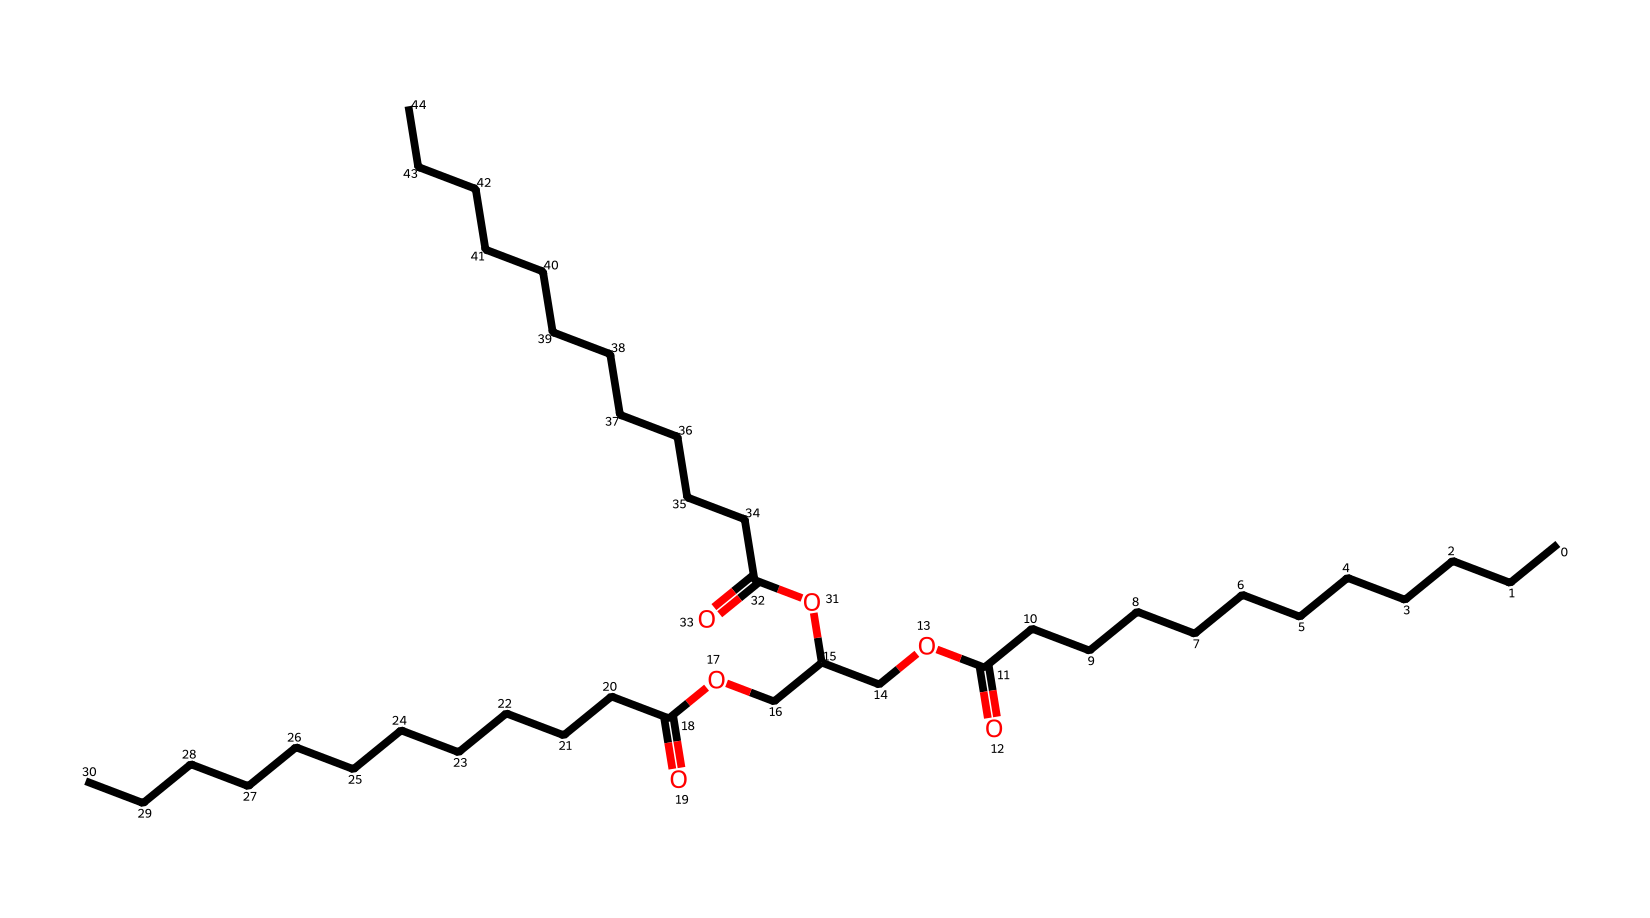How many carbon atoms are present in the structure? By examining the SMILES representation, each "C" represents a carbon atom. Counting all the "C" entries yields a total of 30 carbon atoms in the structure.
Answer: 30 What type of lipid is represented by this molecular structure? The structure represents a triacylglycerol, as indicated by the presence of three ester groups (indicated by "O" linked to "C"), which is a characteristic of triglycerides (or triglycerols).
Answer: triacylglycerol How many double bonds are found in this chemical? In the SMILES notation, there are no occurrences of "=" between any of the carbon atoms, indicating that the structure contains no double bonds, typical of saturated fats found in coconut oil.
Answer: 0 What functional groups can be identified in this molecule? The molecule features ester functional groups (due to the -COO- sequences) and a carboxylic acid group (due to the "C(=O)O" sequence), which are characteristic of fatty acids and triglycerides.
Answer: ester, carboxylic acid What physical property might this molecule exhibit due to its long hydrocarbon chains? The long hydrocarbon chains contribute to the molecule's lipid nature, giving it hydrophobic properties, which would lead to it being a liquid at room temperature. This is typical for many lipids.
Answer: hydrophobic What indicates the presence of saturated fatty acids in the structure? The absence of double bonds between carbon atoms in the SMILES notation signifies that all carbon to carbon bonds are single bonds, indicating that the molecule consists entirely of saturated fatty acids.
Answer: saturated fatty acids How many ester linkages are present in this lipids structure? The structure includes three ester linkages, as identified by the three occurrences of –COO– connections in the SMILES, which is consistent with the three fatty acid chains bound to glycerol in triacylglycerols.
Answer: 3 